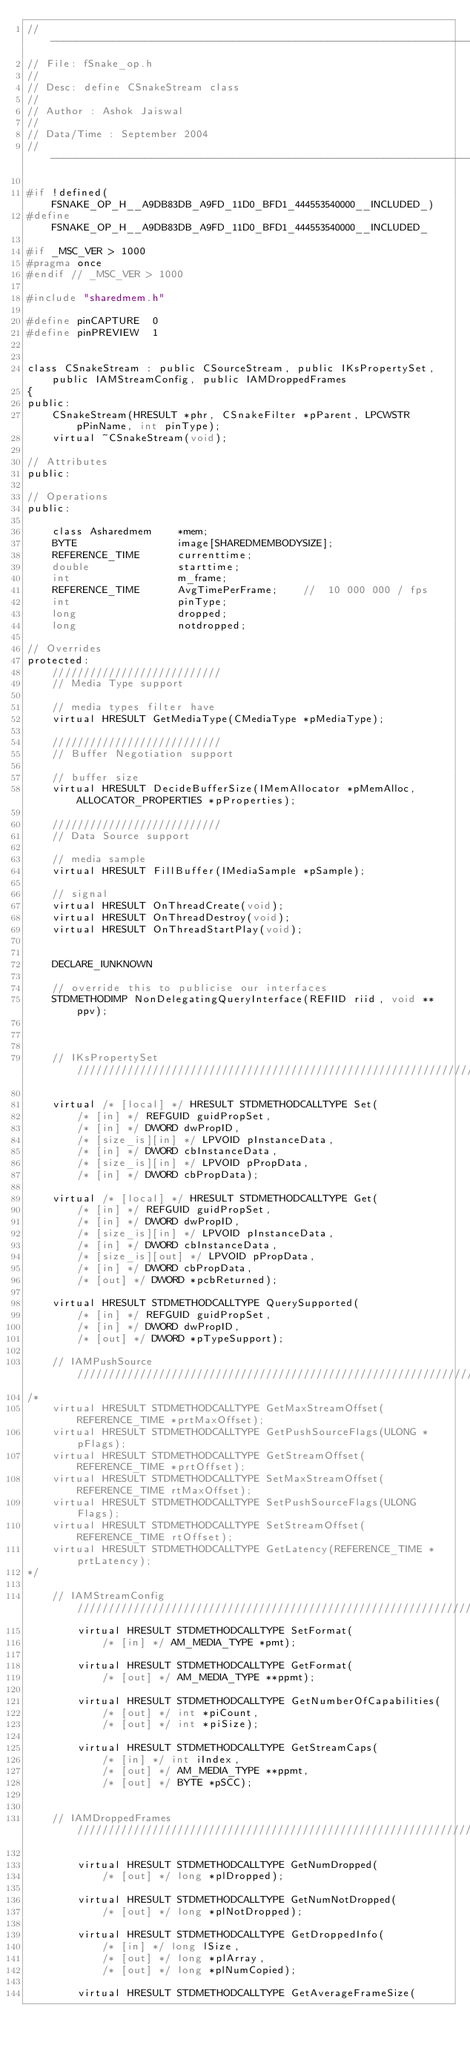<code> <loc_0><loc_0><loc_500><loc_500><_C_>//------------------------------------------------------------------------------
// File: fSnake_op.h
//
// Desc: define CSnakeStream class
//
// Author : Ashok Jaiswal
//
// Data/Time : September 2004
//------------------------------------------------------------------------------

#if !defined(FSNAKE_OP_H__A9DB83DB_A9FD_11D0_BFD1_444553540000__INCLUDED_)
#define FSNAKE_OP_H__A9DB83DB_A9FD_11D0_BFD1_444553540000__INCLUDED_

#if _MSC_VER > 1000
#pragma once
#endif // _MSC_VER > 1000

#include "sharedmem.h"

#define pinCAPTURE	0
#define pinPREVIEW	1


class CSnakeStream : public CSourceStream, public IKsPropertySet, public IAMStreamConfig, public IAMDroppedFrames
{
public:
	CSnakeStream(HRESULT *phr, CSnakeFilter *pParent, LPCWSTR pPinName, int pinType);
	virtual ~CSnakeStream(void);

// Attributes
public:

// Operations
public:

	class Asharedmem	*mem;
	BYTE				image[SHAREDMEMBODYSIZE];
	REFERENCE_TIME		currenttime;
	double				starttime;
	int					m_frame;
	REFERENCE_TIME		AvgTimePerFrame;	//	10 000 000 / fps
	int					pinType;
	long				dropped;
	long				notdropped;

// Overrides
protected:
	///////////////////////////
	// Media Type support

	// media types filter have
	virtual HRESULT GetMediaType(CMediaType *pMediaType);

	///////////////////////////
	// Buffer Negotiation support

	// buffer size
	virtual HRESULT DecideBufferSize(IMemAllocator *pMemAlloc, ALLOCATOR_PROPERTIES *pProperties);

	///////////////////////////
	// Data Source support

	// media sample
	virtual HRESULT FillBuffer(IMediaSample *pSample);

	// signal
	virtual HRESULT OnThreadCreate(void);
	virtual HRESULT OnThreadDestroy(void);
	virtual HRESULT OnThreadStartPlay(void);


    DECLARE_IUNKNOWN

    // override this to publicise our interfaces
    STDMETHODIMP NonDelegatingQueryInterface(REFIID riid, void **ppv);


	
	// IKsPropertySet /////////////////////////////////////////////////////////////////////////////////////:

    virtual /* [local] */ HRESULT STDMETHODCALLTYPE Set( 
        /* [in] */ REFGUID guidPropSet,
        /* [in] */ DWORD dwPropID,
        /* [size_is][in] */ LPVOID pInstanceData,
        /* [in] */ DWORD cbInstanceData,
        /* [size_is][in] */ LPVOID pPropData,
        /* [in] */ DWORD cbPropData);
    
    virtual /* [local] */ HRESULT STDMETHODCALLTYPE Get( 
        /* [in] */ REFGUID guidPropSet,
        /* [in] */ DWORD dwPropID,
        /* [size_is][in] */ LPVOID pInstanceData,
        /* [in] */ DWORD cbInstanceData,
        /* [size_is][out] */ LPVOID pPropData,
        /* [in] */ DWORD cbPropData,
        /* [out] */ DWORD *pcbReturned);
    
    virtual HRESULT STDMETHODCALLTYPE QuerySupported( 
        /* [in] */ REFGUID guidPropSet,
        /* [in] */ DWORD dwPropID,
        /* [out] */ DWORD *pTypeSupport);

	// IAMPushSource /////////////////////////////////////////////////////////////////////////////////////:
/*
	virtual HRESULT STDMETHODCALLTYPE GetMaxStreamOffset(REFERENCE_TIME *prtMaxOffset);
	virtual HRESULT STDMETHODCALLTYPE GetPushSourceFlags(ULONG *pFlags);
	virtual HRESULT STDMETHODCALLTYPE GetStreamOffset(REFERENCE_TIME *prtOffset);
	virtual HRESULT STDMETHODCALLTYPE SetMaxStreamOffset(REFERENCE_TIME rtMaxOffset);
	virtual HRESULT STDMETHODCALLTYPE SetPushSourceFlags(ULONG Flags);
	virtual HRESULT STDMETHODCALLTYPE SetStreamOffset(REFERENCE_TIME rtOffset);
	virtual HRESULT STDMETHODCALLTYPE GetLatency(REFERENCE_TIME *prtLatency);
*/

	// IAMStreamConfig /////////////////////////////////////////////////////////////////////////////////////
        virtual HRESULT STDMETHODCALLTYPE SetFormat( 
            /* [in] */ AM_MEDIA_TYPE *pmt);
        
        virtual HRESULT STDMETHODCALLTYPE GetFormat( 
            /* [out] */ AM_MEDIA_TYPE **ppmt);
        
        virtual HRESULT STDMETHODCALLTYPE GetNumberOfCapabilities( 
            /* [out] */ int *piCount,
            /* [out] */ int *piSize);
        
        virtual HRESULT STDMETHODCALLTYPE GetStreamCaps( 
            /* [in] */ int iIndex,
            /* [out] */ AM_MEDIA_TYPE **ppmt,
            /* [out] */ BYTE *pSCC);


	// IAMDroppedFrames /////////////////////////////////////////////////////////////////////////////////////

        virtual HRESULT STDMETHODCALLTYPE GetNumDropped( 
            /* [out] */ long *plDropped);
        
        virtual HRESULT STDMETHODCALLTYPE GetNumNotDropped( 
            /* [out] */ long *plNotDropped);
        
        virtual HRESULT STDMETHODCALLTYPE GetDroppedInfo( 
            /* [in] */ long lSize,
            /* [out] */ long *plArray,
            /* [out] */ long *plNumCopied);
        
        virtual HRESULT STDMETHODCALLTYPE GetAverageFrameSize( </code> 